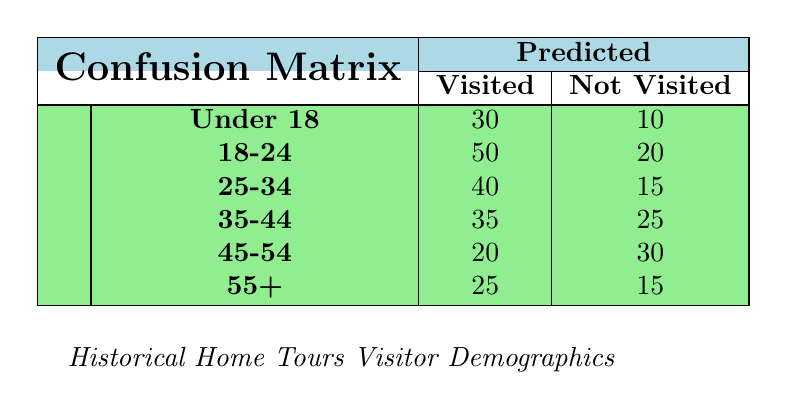What is the total number of visitors under 18 who visited the historical home tours? From the table, we see that 30 visitors under 18 have visited the tours.
Answer: 30 How many visitors aged 35-44 did not visit the historical home tours? According to the table, there are 25 visitors aged 35-44 who did not visit.
Answer: 25 What is the total number of visitors aged 18-24? To find the total number for this age group, we add the number of those who visited (50) and those who did not (20) which equals 70.
Answer: 70 Is it true that more than 50% of visitors aged 25-34 visited the historical home tours? There are 40 visitors aged 25-34 who visited out of a total of 55 (40 who visited + 15 who did not), which is approximately 72.73%, confirming it's more than 50%.
Answer: Yes What is the difference in the number of visitors who did not visit between the age groups 45-54 and 55+? The total number of visitors aged 45-54 who did not visit is 30, and for those aged 55+ it's 15. Therefore, the difference is 30 - 15 = 15.
Answer: 15 How many total visitors are there across all age groups who have visited? Adding the counts of those who visited across all age groups: 30 (Under 18) + 50 (18-24) + 40 (25-34) + 35 (35-44) + 20 (45-54) + 25 (55+) gives a total of 200 visitors who have visited.
Answer: 200 What age group had the highest number of visitors who did not visit? The age group 45-54 had the highest number of visitors who did not visit (30), compared to other age groups.
Answer: 45-54 How many visitors overall did not visit the historical home tours? To calculate this, we sum the counts of those who did not visit: 10 (Under 18) + 20 (18-24) + 15 (25-34) + 25 (35-44) + 30 (45-54) + 15 (55+), resulting in a total of 115 visitors who did not visit.
Answer: 115 